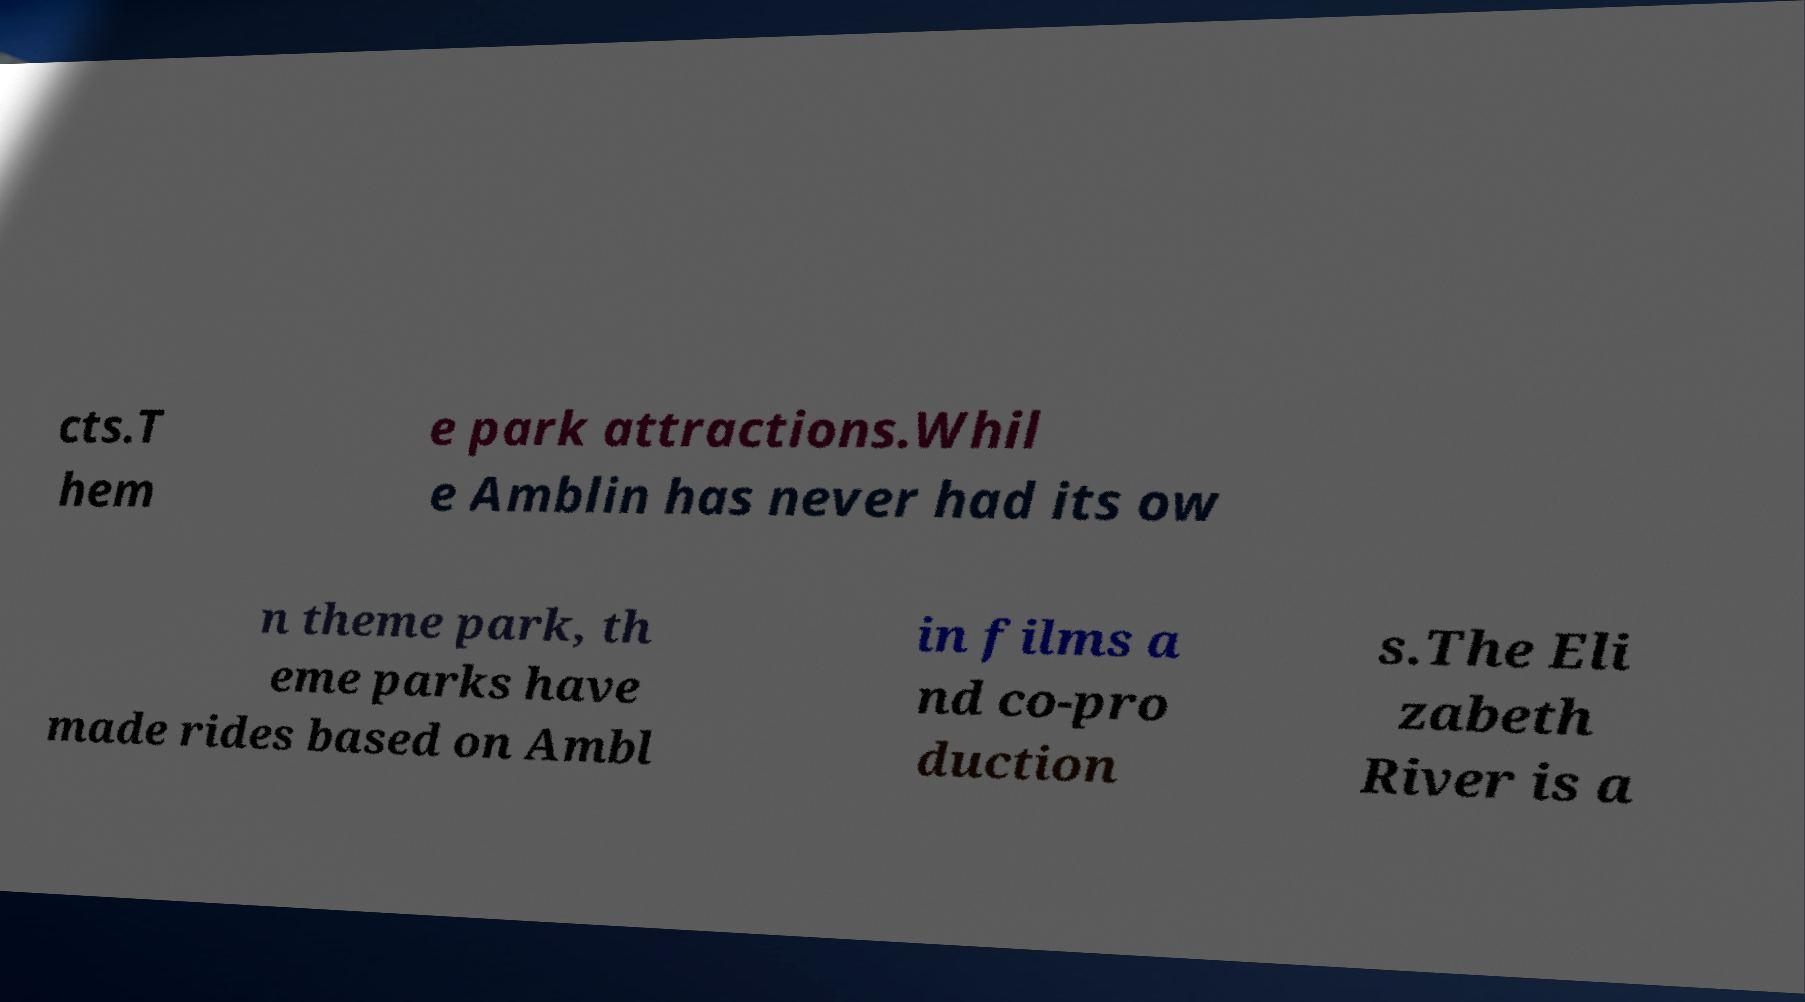There's text embedded in this image that I need extracted. Can you transcribe it verbatim? cts.T hem e park attractions.Whil e Amblin has never had its ow n theme park, th eme parks have made rides based on Ambl in films a nd co-pro duction s.The Eli zabeth River is a 